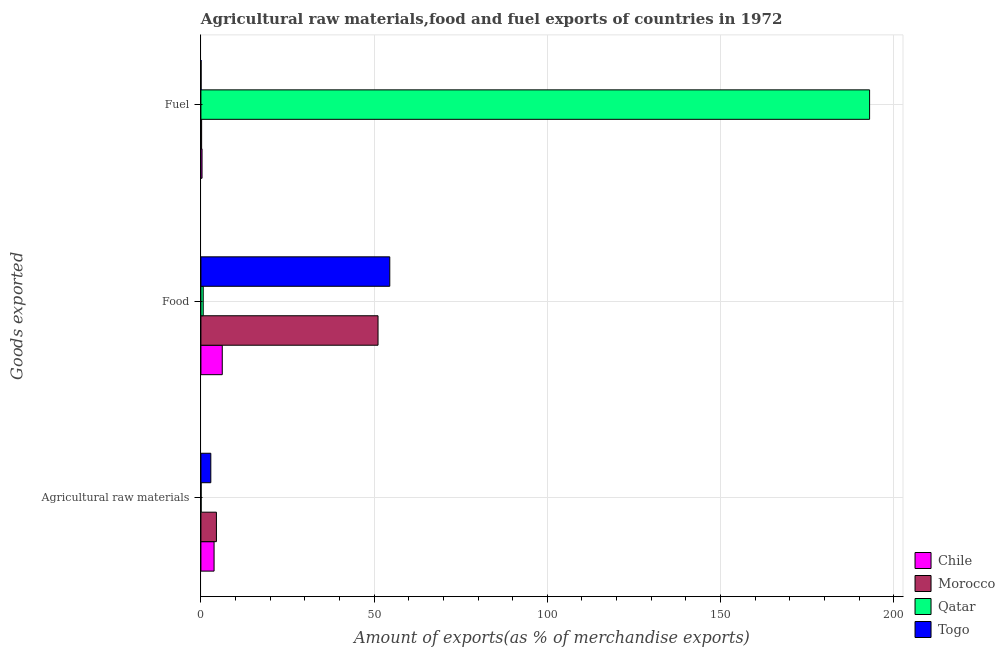How many different coloured bars are there?
Give a very brief answer. 4. Are the number of bars per tick equal to the number of legend labels?
Offer a terse response. Yes. Are the number of bars on each tick of the Y-axis equal?
Give a very brief answer. Yes. How many bars are there on the 2nd tick from the top?
Give a very brief answer. 4. What is the label of the 2nd group of bars from the top?
Offer a very short reply. Food. What is the percentage of food exports in Togo?
Offer a very short reply. 54.52. Across all countries, what is the maximum percentage of food exports?
Ensure brevity in your answer.  54.52. Across all countries, what is the minimum percentage of raw materials exports?
Give a very brief answer. 0.06. In which country was the percentage of raw materials exports maximum?
Offer a very short reply. Morocco. In which country was the percentage of fuel exports minimum?
Keep it short and to the point. Togo. What is the total percentage of food exports in the graph?
Your response must be concise. 112.48. What is the difference between the percentage of food exports in Morocco and that in Chile?
Keep it short and to the point. 44.97. What is the difference between the percentage of fuel exports in Chile and the percentage of food exports in Morocco?
Provide a succinct answer. -50.8. What is the average percentage of fuel exports per country?
Provide a short and direct response. 48.4. What is the difference between the percentage of food exports and percentage of fuel exports in Qatar?
Make the answer very short. -192.37. In how many countries, is the percentage of fuel exports greater than 40 %?
Make the answer very short. 1. What is the ratio of the percentage of food exports in Togo to that in Qatar?
Make the answer very short. 81.97. Is the difference between the percentage of food exports in Qatar and Chile greater than the difference between the percentage of fuel exports in Qatar and Chile?
Offer a very short reply. No. What is the difference between the highest and the second highest percentage of food exports?
Make the answer very short. 3.39. What is the difference between the highest and the lowest percentage of fuel exports?
Your response must be concise. 192.99. In how many countries, is the percentage of raw materials exports greater than the average percentage of raw materials exports taken over all countries?
Offer a terse response. 3. Is the sum of the percentage of fuel exports in Togo and Qatar greater than the maximum percentage of raw materials exports across all countries?
Your answer should be very brief. Yes. What does the 2nd bar from the top in Food represents?
Provide a succinct answer. Qatar. What does the 4th bar from the bottom in Food represents?
Ensure brevity in your answer.  Togo. How many countries are there in the graph?
Offer a terse response. 4. What is the difference between two consecutive major ticks on the X-axis?
Your answer should be very brief. 50. Are the values on the major ticks of X-axis written in scientific E-notation?
Provide a succinct answer. No. Does the graph contain grids?
Provide a succinct answer. Yes. Where does the legend appear in the graph?
Offer a very short reply. Bottom right. How are the legend labels stacked?
Keep it short and to the point. Vertical. What is the title of the graph?
Your answer should be very brief. Agricultural raw materials,food and fuel exports of countries in 1972. What is the label or title of the X-axis?
Ensure brevity in your answer.  Amount of exports(as % of merchandise exports). What is the label or title of the Y-axis?
Provide a short and direct response. Goods exported. What is the Amount of exports(as % of merchandise exports) of Chile in Agricultural raw materials?
Your answer should be compact. 3.8. What is the Amount of exports(as % of merchandise exports) in Morocco in Agricultural raw materials?
Ensure brevity in your answer.  4.48. What is the Amount of exports(as % of merchandise exports) in Qatar in Agricultural raw materials?
Your answer should be very brief. 0.06. What is the Amount of exports(as % of merchandise exports) in Togo in Agricultural raw materials?
Make the answer very short. 2.86. What is the Amount of exports(as % of merchandise exports) in Chile in Food?
Offer a very short reply. 6.16. What is the Amount of exports(as % of merchandise exports) in Morocco in Food?
Your answer should be compact. 51.13. What is the Amount of exports(as % of merchandise exports) in Qatar in Food?
Keep it short and to the point. 0.67. What is the Amount of exports(as % of merchandise exports) in Togo in Food?
Keep it short and to the point. 54.52. What is the Amount of exports(as % of merchandise exports) of Chile in Fuel?
Provide a short and direct response. 0.33. What is the Amount of exports(as % of merchandise exports) of Morocco in Fuel?
Provide a short and direct response. 0.21. What is the Amount of exports(as % of merchandise exports) of Qatar in Fuel?
Your response must be concise. 193.04. What is the Amount of exports(as % of merchandise exports) of Togo in Fuel?
Offer a very short reply. 0.05. Across all Goods exported, what is the maximum Amount of exports(as % of merchandise exports) in Chile?
Your response must be concise. 6.16. Across all Goods exported, what is the maximum Amount of exports(as % of merchandise exports) of Morocco?
Ensure brevity in your answer.  51.13. Across all Goods exported, what is the maximum Amount of exports(as % of merchandise exports) of Qatar?
Offer a very short reply. 193.04. Across all Goods exported, what is the maximum Amount of exports(as % of merchandise exports) in Togo?
Your answer should be compact. 54.52. Across all Goods exported, what is the minimum Amount of exports(as % of merchandise exports) in Chile?
Ensure brevity in your answer.  0.33. Across all Goods exported, what is the minimum Amount of exports(as % of merchandise exports) of Morocco?
Offer a terse response. 0.21. Across all Goods exported, what is the minimum Amount of exports(as % of merchandise exports) in Qatar?
Offer a very short reply. 0.06. Across all Goods exported, what is the minimum Amount of exports(as % of merchandise exports) of Togo?
Provide a succinct answer. 0.05. What is the total Amount of exports(as % of merchandise exports) in Chile in the graph?
Offer a terse response. 10.29. What is the total Amount of exports(as % of merchandise exports) in Morocco in the graph?
Your response must be concise. 55.81. What is the total Amount of exports(as % of merchandise exports) of Qatar in the graph?
Your answer should be very brief. 193.76. What is the total Amount of exports(as % of merchandise exports) of Togo in the graph?
Keep it short and to the point. 57.42. What is the difference between the Amount of exports(as % of merchandise exports) of Chile in Agricultural raw materials and that in Food?
Your answer should be compact. -2.36. What is the difference between the Amount of exports(as % of merchandise exports) in Morocco in Agricultural raw materials and that in Food?
Offer a terse response. -46.66. What is the difference between the Amount of exports(as % of merchandise exports) of Qatar in Agricultural raw materials and that in Food?
Your answer should be very brief. -0.6. What is the difference between the Amount of exports(as % of merchandise exports) in Togo in Agricultural raw materials and that in Food?
Make the answer very short. -51.66. What is the difference between the Amount of exports(as % of merchandise exports) of Chile in Agricultural raw materials and that in Fuel?
Keep it short and to the point. 3.47. What is the difference between the Amount of exports(as % of merchandise exports) of Morocco in Agricultural raw materials and that in Fuel?
Your response must be concise. 4.27. What is the difference between the Amount of exports(as % of merchandise exports) in Qatar in Agricultural raw materials and that in Fuel?
Provide a short and direct response. -192.98. What is the difference between the Amount of exports(as % of merchandise exports) in Togo in Agricultural raw materials and that in Fuel?
Provide a short and direct response. 2.81. What is the difference between the Amount of exports(as % of merchandise exports) in Chile in Food and that in Fuel?
Offer a terse response. 5.83. What is the difference between the Amount of exports(as % of merchandise exports) in Morocco in Food and that in Fuel?
Offer a very short reply. 50.92. What is the difference between the Amount of exports(as % of merchandise exports) in Qatar in Food and that in Fuel?
Keep it short and to the point. -192.37. What is the difference between the Amount of exports(as % of merchandise exports) in Togo in Food and that in Fuel?
Your response must be concise. 54.48. What is the difference between the Amount of exports(as % of merchandise exports) in Chile in Agricultural raw materials and the Amount of exports(as % of merchandise exports) in Morocco in Food?
Provide a short and direct response. -47.33. What is the difference between the Amount of exports(as % of merchandise exports) of Chile in Agricultural raw materials and the Amount of exports(as % of merchandise exports) of Qatar in Food?
Ensure brevity in your answer.  3.13. What is the difference between the Amount of exports(as % of merchandise exports) in Chile in Agricultural raw materials and the Amount of exports(as % of merchandise exports) in Togo in Food?
Offer a terse response. -50.72. What is the difference between the Amount of exports(as % of merchandise exports) of Morocco in Agricultural raw materials and the Amount of exports(as % of merchandise exports) of Qatar in Food?
Make the answer very short. 3.81. What is the difference between the Amount of exports(as % of merchandise exports) of Morocco in Agricultural raw materials and the Amount of exports(as % of merchandise exports) of Togo in Food?
Provide a short and direct response. -50.05. What is the difference between the Amount of exports(as % of merchandise exports) in Qatar in Agricultural raw materials and the Amount of exports(as % of merchandise exports) in Togo in Food?
Ensure brevity in your answer.  -54.46. What is the difference between the Amount of exports(as % of merchandise exports) in Chile in Agricultural raw materials and the Amount of exports(as % of merchandise exports) in Morocco in Fuel?
Your response must be concise. 3.59. What is the difference between the Amount of exports(as % of merchandise exports) of Chile in Agricultural raw materials and the Amount of exports(as % of merchandise exports) of Qatar in Fuel?
Provide a succinct answer. -189.24. What is the difference between the Amount of exports(as % of merchandise exports) in Chile in Agricultural raw materials and the Amount of exports(as % of merchandise exports) in Togo in Fuel?
Ensure brevity in your answer.  3.75. What is the difference between the Amount of exports(as % of merchandise exports) in Morocco in Agricultural raw materials and the Amount of exports(as % of merchandise exports) in Qatar in Fuel?
Keep it short and to the point. -188.56. What is the difference between the Amount of exports(as % of merchandise exports) in Morocco in Agricultural raw materials and the Amount of exports(as % of merchandise exports) in Togo in Fuel?
Make the answer very short. 4.43. What is the difference between the Amount of exports(as % of merchandise exports) in Qatar in Agricultural raw materials and the Amount of exports(as % of merchandise exports) in Togo in Fuel?
Offer a terse response. 0.02. What is the difference between the Amount of exports(as % of merchandise exports) of Chile in Food and the Amount of exports(as % of merchandise exports) of Morocco in Fuel?
Your answer should be very brief. 5.96. What is the difference between the Amount of exports(as % of merchandise exports) in Chile in Food and the Amount of exports(as % of merchandise exports) in Qatar in Fuel?
Provide a succinct answer. -186.87. What is the difference between the Amount of exports(as % of merchandise exports) in Chile in Food and the Amount of exports(as % of merchandise exports) in Togo in Fuel?
Give a very brief answer. 6.12. What is the difference between the Amount of exports(as % of merchandise exports) in Morocco in Food and the Amount of exports(as % of merchandise exports) in Qatar in Fuel?
Ensure brevity in your answer.  -141.9. What is the difference between the Amount of exports(as % of merchandise exports) of Morocco in Food and the Amount of exports(as % of merchandise exports) of Togo in Fuel?
Offer a terse response. 51.09. What is the difference between the Amount of exports(as % of merchandise exports) of Qatar in Food and the Amount of exports(as % of merchandise exports) of Togo in Fuel?
Provide a short and direct response. 0.62. What is the average Amount of exports(as % of merchandise exports) of Chile per Goods exported?
Offer a terse response. 3.43. What is the average Amount of exports(as % of merchandise exports) of Morocco per Goods exported?
Your response must be concise. 18.6. What is the average Amount of exports(as % of merchandise exports) of Qatar per Goods exported?
Make the answer very short. 64.59. What is the average Amount of exports(as % of merchandise exports) in Togo per Goods exported?
Offer a terse response. 19.14. What is the difference between the Amount of exports(as % of merchandise exports) of Chile and Amount of exports(as % of merchandise exports) of Morocco in Agricultural raw materials?
Provide a succinct answer. -0.68. What is the difference between the Amount of exports(as % of merchandise exports) in Chile and Amount of exports(as % of merchandise exports) in Qatar in Agricultural raw materials?
Provide a succinct answer. 3.74. What is the difference between the Amount of exports(as % of merchandise exports) in Chile and Amount of exports(as % of merchandise exports) in Togo in Agricultural raw materials?
Ensure brevity in your answer.  0.94. What is the difference between the Amount of exports(as % of merchandise exports) in Morocco and Amount of exports(as % of merchandise exports) in Qatar in Agricultural raw materials?
Provide a succinct answer. 4.41. What is the difference between the Amount of exports(as % of merchandise exports) in Morocco and Amount of exports(as % of merchandise exports) in Togo in Agricultural raw materials?
Your answer should be very brief. 1.62. What is the difference between the Amount of exports(as % of merchandise exports) in Qatar and Amount of exports(as % of merchandise exports) in Togo in Agricultural raw materials?
Ensure brevity in your answer.  -2.8. What is the difference between the Amount of exports(as % of merchandise exports) in Chile and Amount of exports(as % of merchandise exports) in Morocco in Food?
Ensure brevity in your answer.  -44.97. What is the difference between the Amount of exports(as % of merchandise exports) in Chile and Amount of exports(as % of merchandise exports) in Qatar in Food?
Your answer should be compact. 5.5. What is the difference between the Amount of exports(as % of merchandise exports) in Chile and Amount of exports(as % of merchandise exports) in Togo in Food?
Your response must be concise. -48.36. What is the difference between the Amount of exports(as % of merchandise exports) in Morocco and Amount of exports(as % of merchandise exports) in Qatar in Food?
Your answer should be very brief. 50.47. What is the difference between the Amount of exports(as % of merchandise exports) of Morocco and Amount of exports(as % of merchandise exports) of Togo in Food?
Give a very brief answer. -3.39. What is the difference between the Amount of exports(as % of merchandise exports) of Qatar and Amount of exports(as % of merchandise exports) of Togo in Food?
Your response must be concise. -53.86. What is the difference between the Amount of exports(as % of merchandise exports) of Chile and Amount of exports(as % of merchandise exports) of Morocco in Fuel?
Give a very brief answer. 0.12. What is the difference between the Amount of exports(as % of merchandise exports) of Chile and Amount of exports(as % of merchandise exports) of Qatar in Fuel?
Your answer should be compact. -192.71. What is the difference between the Amount of exports(as % of merchandise exports) of Chile and Amount of exports(as % of merchandise exports) of Togo in Fuel?
Offer a terse response. 0.28. What is the difference between the Amount of exports(as % of merchandise exports) of Morocco and Amount of exports(as % of merchandise exports) of Qatar in Fuel?
Make the answer very short. -192.83. What is the difference between the Amount of exports(as % of merchandise exports) in Morocco and Amount of exports(as % of merchandise exports) in Togo in Fuel?
Make the answer very short. 0.16. What is the difference between the Amount of exports(as % of merchandise exports) of Qatar and Amount of exports(as % of merchandise exports) of Togo in Fuel?
Make the answer very short. 192.99. What is the ratio of the Amount of exports(as % of merchandise exports) in Chile in Agricultural raw materials to that in Food?
Your answer should be compact. 0.62. What is the ratio of the Amount of exports(as % of merchandise exports) of Morocco in Agricultural raw materials to that in Food?
Your response must be concise. 0.09. What is the ratio of the Amount of exports(as % of merchandise exports) of Qatar in Agricultural raw materials to that in Food?
Offer a very short reply. 0.09. What is the ratio of the Amount of exports(as % of merchandise exports) of Togo in Agricultural raw materials to that in Food?
Make the answer very short. 0.05. What is the ratio of the Amount of exports(as % of merchandise exports) of Chile in Agricultural raw materials to that in Fuel?
Your answer should be very brief. 11.58. What is the ratio of the Amount of exports(as % of merchandise exports) of Morocco in Agricultural raw materials to that in Fuel?
Provide a succinct answer. 21.64. What is the ratio of the Amount of exports(as % of merchandise exports) in Qatar in Agricultural raw materials to that in Fuel?
Provide a succinct answer. 0. What is the ratio of the Amount of exports(as % of merchandise exports) in Togo in Agricultural raw materials to that in Fuel?
Provide a succinct answer. 62.67. What is the ratio of the Amount of exports(as % of merchandise exports) in Chile in Food to that in Fuel?
Ensure brevity in your answer.  18.79. What is the ratio of the Amount of exports(as % of merchandise exports) in Morocco in Food to that in Fuel?
Your answer should be compact. 247.29. What is the ratio of the Amount of exports(as % of merchandise exports) of Qatar in Food to that in Fuel?
Your response must be concise. 0. What is the ratio of the Amount of exports(as % of merchandise exports) of Togo in Food to that in Fuel?
Your answer should be compact. 1196.07. What is the difference between the highest and the second highest Amount of exports(as % of merchandise exports) of Chile?
Provide a succinct answer. 2.36. What is the difference between the highest and the second highest Amount of exports(as % of merchandise exports) in Morocco?
Ensure brevity in your answer.  46.66. What is the difference between the highest and the second highest Amount of exports(as % of merchandise exports) of Qatar?
Keep it short and to the point. 192.37. What is the difference between the highest and the second highest Amount of exports(as % of merchandise exports) in Togo?
Offer a very short reply. 51.66. What is the difference between the highest and the lowest Amount of exports(as % of merchandise exports) of Chile?
Give a very brief answer. 5.83. What is the difference between the highest and the lowest Amount of exports(as % of merchandise exports) in Morocco?
Your response must be concise. 50.92. What is the difference between the highest and the lowest Amount of exports(as % of merchandise exports) in Qatar?
Provide a succinct answer. 192.98. What is the difference between the highest and the lowest Amount of exports(as % of merchandise exports) of Togo?
Ensure brevity in your answer.  54.48. 